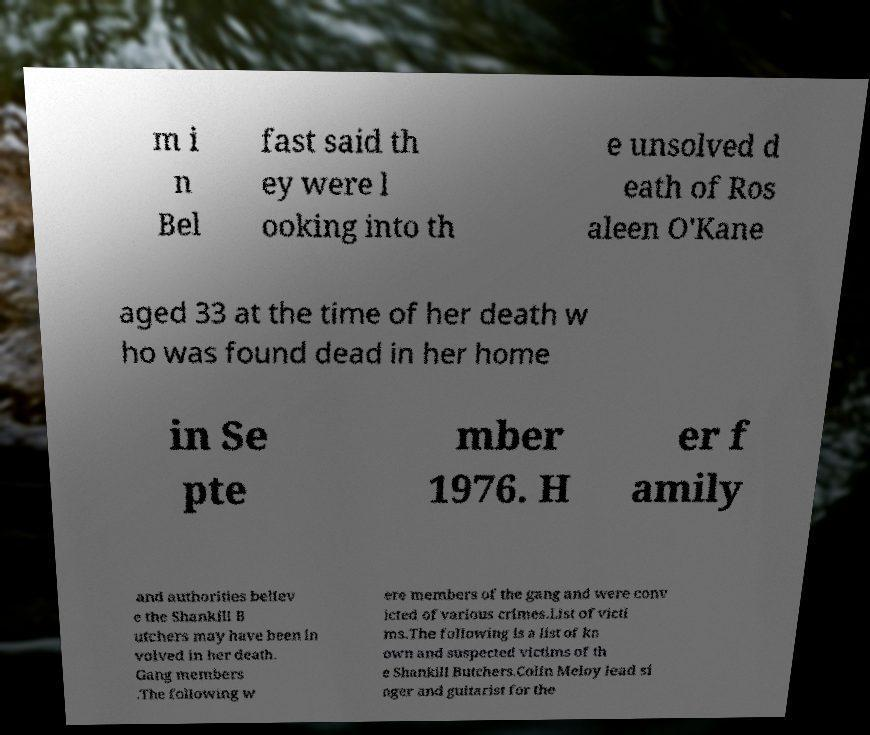Could you extract and type out the text from this image? m i n Bel fast said th ey were l ooking into th e unsolved d eath of Ros aleen O'Kane aged 33 at the time of her death w ho was found dead in her home in Se pte mber 1976. H er f amily and authorities believ e the Shankill B utchers may have been in volved in her death. Gang members .The following w ere members of the gang and were conv icted of various crimes.List of victi ms.The following is a list of kn own and suspected victims of th e Shankill Butchers.Colin Meloy lead si nger and guitarist for the 